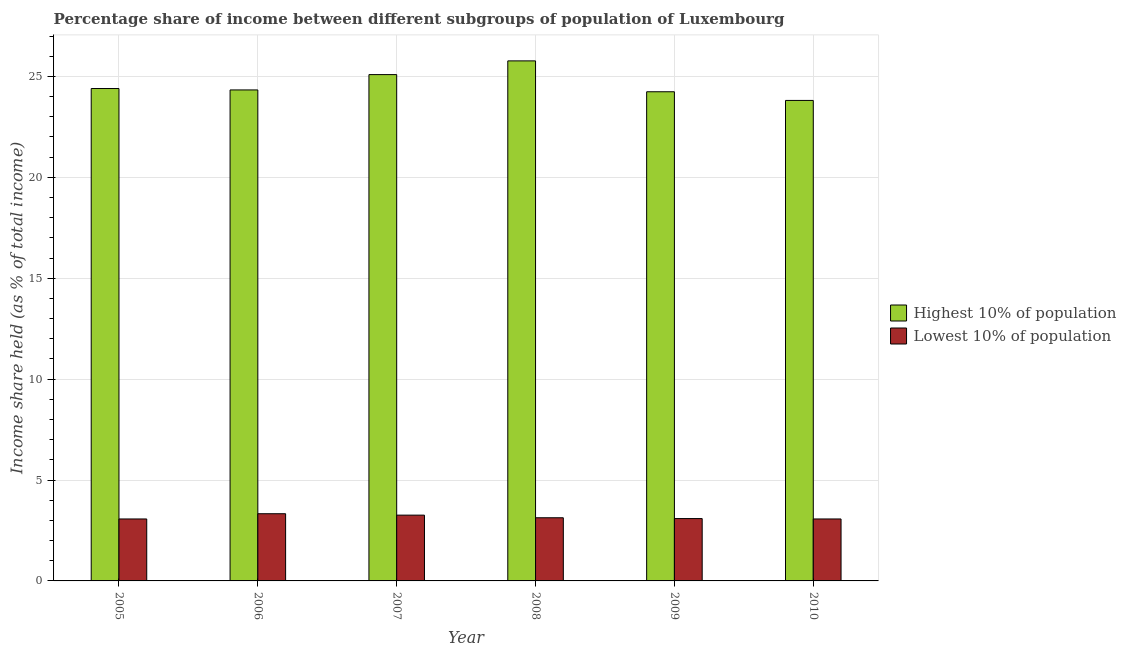How many different coloured bars are there?
Your answer should be very brief. 2. How many groups of bars are there?
Offer a terse response. 6. Are the number of bars on each tick of the X-axis equal?
Your response must be concise. Yes. How many bars are there on the 4th tick from the left?
Give a very brief answer. 2. What is the label of the 4th group of bars from the left?
Offer a terse response. 2008. What is the income share held by highest 10% of the population in 2010?
Your answer should be compact. 23.81. Across all years, what is the maximum income share held by highest 10% of the population?
Your answer should be very brief. 25.77. Across all years, what is the minimum income share held by lowest 10% of the population?
Your response must be concise. 3.07. In which year was the income share held by highest 10% of the population minimum?
Make the answer very short. 2010. What is the total income share held by highest 10% of the population in the graph?
Make the answer very short. 147.64. What is the difference between the income share held by highest 10% of the population in 2005 and that in 2007?
Offer a very short reply. -0.69. What is the difference between the income share held by highest 10% of the population in 2005 and the income share held by lowest 10% of the population in 2008?
Your response must be concise. -1.37. What is the average income share held by lowest 10% of the population per year?
Offer a terse response. 3.16. In how many years, is the income share held by highest 10% of the population greater than 8 %?
Keep it short and to the point. 6. What is the ratio of the income share held by highest 10% of the population in 2006 to that in 2010?
Your answer should be very brief. 1.02. What is the difference between the highest and the second highest income share held by highest 10% of the population?
Provide a short and direct response. 0.68. What is the difference between the highest and the lowest income share held by highest 10% of the population?
Make the answer very short. 1.96. In how many years, is the income share held by highest 10% of the population greater than the average income share held by highest 10% of the population taken over all years?
Your answer should be very brief. 2. Is the sum of the income share held by highest 10% of the population in 2006 and 2010 greater than the maximum income share held by lowest 10% of the population across all years?
Make the answer very short. Yes. What does the 2nd bar from the left in 2009 represents?
Your answer should be very brief. Lowest 10% of population. What does the 2nd bar from the right in 2007 represents?
Offer a very short reply. Highest 10% of population. How many bars are there?
Your answer should be compact. 12. Are all the bars in the graph horizontal?
Offer a terse response. No. How many years are there in the graph?
Provide a succinct answer. 6. Are the values on the major ticks of Y-axis written in scientific E-notation?
Provide a succinct answer. No. Does the graph contain grids?
Provide a succinct answer. Yes. How many legend labels are there?
Your answer should be very brief. 2. How are the legend labels stacked?
Keep it short and to the point. Vertical. What is the title of the graph?
Your response must be concise. Percentage share of income between different subgroups of population of Luxembourg. Does "By country of asylum" appear as one of the legend labels in the graph?
Your answer should be compact. No. What is the label or title of the X-axis?
Provide a succinct answer. Year. What is the label or title of the Y-axis?
Offer a very short reply. Income share held (as % of total income). What is the Income share held (as % of total income) in Highest 10% of population in 2005?
Your answer should be compact. 24.4. What is the Income share held (as % of total income) in Lowest 10% of population in 2005?
Make the answer very short. 3.07. What is the Income share held (as % of total income) in Highest 10% of population in 2006?
Keep it short and to the point. 24.33. What is the Income share held (as % of total income) in Lowest 10% of population in 2006?
Provide a succinct answer. 3.33. What is the Income share held (as % of total income) in Highest 10% of population in 2007?
Offer a very short reply. 25.09. What is the Income share held (as % of total income) in Lowest 10% of population in 2007?
Ensure brevity in your answer.  3.26. What is the Income share held (as % of total income) in Highest 10% of population in 2008?
Your response must be concise. 25.77. What is the Income share held (as % of total income) of Lowest 10% of population in 2008?
Offer a very short reply. 3.13. What is the Income share held (as % of total income) in Highest 10% of population in 2009?
Provide a succinct answer. 24.24. What is the Income share held (as % of total income) of Lowest 10% of population in 2009?
Make the answer very short. 3.09. What is the Income share held (as % of total income) in Highest 10% of population in 2010?
Your answer should be very brief. 23.81. What is the Income share held (as % of total income) of Lowest 10% of population in 2010?
Offer a terse response. 3.07. Across all years, what is the maximum Income share held (as % of total income) of Highest 10% of population?
Keep it short and to the point. 25.77. Across all years, what is the maximum Income share held (as % of total income) in Lowest 10% of population?
Your answer should be very brief. 3.33. Across all years, what is the minimum Income share held (as % of total income) of Highest 10% of population?
Keep it short and to the point. 23.81. Across all years, what is the minimum Income share held (as % of total income) in Lowest 10% of population?
Your answer should be very brief. 3.07. What is the total Income share held (as % of total income) in Highest 10% of population in the graph?
Give a very brief answer. 147.64. What is the total Income share held (as % of total income) of Lowest 10% of population in the graph?
Your response must be concise. 18.95. What is the difference between the Income share held (as % of total income) in Highest 10% of population in 2005 and that in 2006?
Your response must be concise. 0.07. What is the difference between the Income share held (as % of total income) of Lowest 10% of population in 2005 and that in 2006?
Provide a succinct answer. -0.26. What is the difference between the Income share held (as % of total income) of Highest 10% of population in 2005 and that in 2007?
Give a very brief answer. -0.69. What is the difference between the Income share held (as % of total income) in Lowest 10% of population in 2005 and that in 2007?
Keep it short and to the point. -0.19. What is the difference between the Income share held (as % of total income) in Highest 10% of population in 2005 and that in 2008?
Offer a terse response. -1.37. What is the difference between the Income share held (as % of total income) in Lowest 10% of population in 2005 and that in 2008?
Offer a terse response. -0.06. What is the difference between the Income share held (as % of total income) in Highest 10% of population in 2005 and that in 2009?
Offer a very short reply. 0.16. What is the difference between the Income share held (as % of total income) in Lowest 10% of population in 2005 and that in 2009?
Give a very brief answer. -0.02. What is the difference between the Income share held (as % of total income) of Highest 10% of population in 2005 and that in 2010?
Your response must be concise. 0.59. What is the difference between the Income share held (as % of total income) in Highest 10% of population in 2006 and that in 2007?
Offer a very short reply. -0.76. What is the difference between the Income share held (as % of total income) in Lowest 10% of population in 2006 and that in 2007?
Your response must be concise. 0.07. What is the difference between the Income share held (as % of total income) of Highest 10% of population in 2006 and that in 2008?
Your answer should be compact. -1.44. What is the difference between the Income share held (as % of total income) of Lowest 10% of population in 2006 and that in 2008?
Provide a short and direct response. 0.2. What is the difference between the Income share held (as % of total income) of Highest 10% of population in 2006 and that in 2009?
Keep it short and to the point. 0.09. What is the difference between the Income share held (as % of total income) in Lowest 10% of population in 2006 and that in 2009?
Make the answer very short. 0.24. What is the difference between the Income share held (as % of total income) of Highest 10% of population in 2006 and that in 2010?
Offer a terse response. 0.52. What is the difference between the Income share held (as % of total income) of Lowest 10% of population in 2006 and that in 2010?
Your answer should be compact. 0.26. What is the difference between the Income share held (as % of total income) in Highest 10% of population in 2007 and that in 2008?
Keep it short and to the point. -0.68. What is the difference between the Income share held (as % of total income) of Lowest 10% of population in 2007 and that in 2008?
Your answer should be very brief. 0.13. What is the difference between the Income share held (as % of total income) in Highest 10% of population in 2007 and that in 2009?
Your answer should be compact. 0.85. What is the difference between the Income share held (as % of total income) of Lowest 10% of population in 2007 and that in 2009?
Offer a terse response. 0.17. What is the difference between the Income share held (as % of total income) in Highest 10% of population in 2007 and that in 2010?
Your answer should be compact. 1.28. What is the difference between the Income share held (as % of total income) of Lowest 10% of population in 2007 and that in 2010?
Keep it short and to the point. 0.19. What is the difference between the Income share held (as % of total income) of Highest 10% of population in 2008 and that in 2009?
Your response must be concise. 1.53. What is the difference between the Income share held (as % of total income) of Highest 10% of population in 2008 and that in 2010?
Your response must be concise. 1.96. What is the difference between the Income share held (as % of total income) of Highest 10% of population in 2009 and that in 2010?
Offer a very short reply. 0.43. What is the difference between the Income share held (as % of total income) in Lowest 10% of population in 2009 and that in 2010?
Provide a succinct answer. 0.02. What is the difference between the Income share held (as % of total income) of Highest 10% of population in 2005 and the Income share held (as % of total income) of Lowest 10% of population in 2006?
Give a very brief answer. 21.07. What is the difference between the Income share held (as % of total income) of Highest 10% of population in 2005 and the Income share held (as % of total income) of Lowest 10% of population in 2007?
Offer a very short reply. 21.14. What is the difference between the Income share held (as % of total income) of Highest 10% of population in 2005 and the Income share held (as % of total income) of Lowest 10% of population in 2008?
Your answer should be very brief. 21.27. What is the difference between the Income share held (as % of total income) of Highest 10% of population in 2005 and the Income share held (as % of total income) of Lowest 10% of population in 2009?
Your answer should be very brief. 21.31. What is the difference between the Income share held (as % of total income) in Highest 10% of population in 2005 and the Income share held (as % of total income) in Lowest 10% of population in 2010?
Offer a terse response. 21.33. What is the difference between the Income share held (as % of total income) of Highest 10% of population in 2006 and the Income share held (as % of total income) of Lowest 10% of population in 2007?
Provide a short and direct response. 21.07. What is the difference between the Income share held (as % of total income) of Highest 10% of population in 2006 and the Income share held (as % of total income) of Lowest 10% of population in 2008?
Make the answer very short. 21.2. What is the difference between the Income share held (as % of total income) in Highest 10% of population in 2006 and the Income share held (as % of total income) in Lowest 10% of population in 2009?
Your answer should be very brief. 21.24. What is the difference between the Income share held (as % of total income) of Highest 10% of population in 2006 and the Income share held (as % of total income) of Lowest 10% of population in 2010?
Provide a short and direct response. 21.26. What is the difference between the Income share held (as % of total income) in Highest 10% of population in 2007 and the Income share held (as % of total income) in Lowest 10% of population in 2008?
Keep it short and to the point. 21.96. What is the difference between the Income share held (as % of total income) in Highest 10% of population in 2007 and the Income share held (as % of total income) in Lowest 10% of population in 2009?
Your answer should be compact. 22. What is the difference between the Income share held (as % of total income) in Highest 10% of population in 2007 and the Income share held (as % of total income) in Lowest 10% of population in 2010?
Offer a terse response. 22.02. What is the difference between the Income share held (as % of total income) in Highest 10% of population in 2008 and the Income share held (as % of total income) in Lowest 10% of population in 2009?
Give a very brief answer. 22.68. What is the difference between the Income share held (as % of total income) of Highest 10% of population in 2008 and the Income share held (as % of total income) of Lowest 10% of population in 2010?
Make the answer very short. 22.7. What is the difference between the Income share held (as % of total income) in Highest 10% of population in 2009 and the Income share held (as % of total income) in Lowest 10% of population in 2010?
Provide a short and direct response. 21.17. What is the average Income share held (as % of total income) of Highest 10% of population per year?
Ensure brevity in your answer.  24.61. What is the average Income share held (as % of total income) in Lowest 10% of population per year?
Make the answer very short. 3.16. In the year 2005, what is the difference between the Income share held (as % of total income) of Highest 10% of population and Income share held (as % of total income) of Lowest 10% of population?
Your response must be concise. 21.33. In the year 2006, what is the difference between the Income share held (as % of total income) of Highest 10% of population and Income share held (as % of total income) of Lowest 10% of population?
Your answer should be very brief. 21. In the year 2007, what is the difference between the Income share held (as % of total income) in Highest 10% of population and Income share held (as % of total income) in Lowest 10% of population?
Your answer should be compact. 21.83. In the year 2008, what is the difference between the Income share held (as % of total income) of Highest 10% of population and Income share held (as % of total income) of Lowest 10% of population?
Provide a succinct answer. 22.64. In the year 2009, what is the difference between the Income share held (as % of total income) in Highest 10% of population and Income share held (as % of total income) in Lowest 10% of population?
Provide a short and direct response. 21.15. In the year 2010, what is the difference between the Income share held (as % of total income) in Highest 10% of population and Income share held (as % of total income) in Lowest 10% of population?
Ensure brevity in your answer.  20.74. What is the ratio of the Income share held (as % of total income) in Lowest 10% of population in 2005 to that in 2006?
Keep it short and to the point. 0.92. What is the ratio of the Income share held (as % of total income) of Highest 10% of population in 2005 to that in 2007?
Ensure brevity in your answer.  0.97. What is the ratio of the Income share held (as % of total income) in Lowest 10% of population in 2005 to that in 2007?
Offer a very short reply. 0.94. What is the ratio of the Income share held (as % of total income) in Highest 10% of population in 2005 to that in 2008?
Your answer should be very brief. 0.95. What is the ratio of the Income share held (as % of total income) of Lowest 10% of population in 2005 to that in 2008?
Ensure brevity in your answer.  0.98. What is the ratio of the Income share held (as % of total income) of Highest 10% of population in 2005 to that in 2009?
Your answer should be very brief. 1.01. What is the ratio of the Income share held (as % of total income) of Lowest 10% of population in 2005 to that in 2009?
Your answer should be very brief. 0.99. What is the ratio of the Income share held (as % of total income) in Highest 10% of population in 2005 to that in 2010?
Offer a very short reply. 1.02. What is the ratio of the Income share held (as % of total income) in Highest 10% of population in 2006 to that in 2007?
Keep it short and to the point. 0.97. What is the ratio of the Income share held (as % of total income) of Lowest 10% of population in 2006 to that in 2007?
Give a very brief answer. 1.02. What is the ratio of the Income share held (as % of total income) in Highest 10% of population in 2006 to that in 2008?
Your answer should be very brief. 0.94. What is the ratio of the Income share held (as % of total income) in Lowest 10% of population in 2006 to that in 2008?
Offer a terse response. 1.06. What is the ratio of the Income share held (as % of total income) of Highest 10% of population in 2006 to that in 2009?
Provide a succinct answer. 1. What is the ratio of the Income share held (as % of total income) in Lowest 10% of population in 2006 to that in 2009?
Ensure brevity in your answer.  1.08. What is the ratio of the Income share held (as % of total income) of Highest 10% of population in 2006 to that in 2010?
Provide a short and direct response. 1.02. What is the ratio of the Income share held (as % of total income) in Lowest 10% of population in 2006 to that in 2010?
Keep it short and to the point. 1.08. What is the ratio of the Income share held (as % of total income) of Highest 10% of population in 2007 to that in 2008?
Offer a terse response. 0.97. What is the ratio of the Income share held (as % of total income) of Lowest 10% of population in 2007 to that in 2008?
Your answer should be compact. 1.04. What is the ratio of the Income share held (as % of total income) of Highest 10% of population in 2007 to that in 2009?
Offer a terse response. 1.04. What is the ratio of the Income share held (as % of total income) in Lowest 10% of population in 2007 to that in 2009?
Your response must be concise. 1.05. What is the ratio of the Income share held (as % of total income) in Highest 10% of population in 2007 to that in 2010?
Offer a terse response. 1.05. What is the ratio of the Income share held (as % of total income) in Lowest 10% of population in 2007 to that in 2010?
Give a very brief answer. 1.06. What is the ratio of the Income share held (as % of total income) in Highest 10% of population in 2008 to that in 2009?
Offer a terse response. 1.06. What is the ratio of the Income share held (as % of total income) of Lowest 10% of population in 2008 to that in 2009?
Provide a short and direct response. 1.01. What is the ratio of the Income share held (as % of total income) in Highest 10% of population in 2008 to that in 2010?
Provide a short and direct response. 1.08. What is the ratio of the Income share held (as % of total income) of Lowest 10% of population in 2008 to that in 2010?
Give a very brief answer. 1.02. What is the ratio of the Income share held (as % of total income) in Highest 10% of population in 2009 to that in 2010?
Your answer should be very brief. 1.02. What is the ratio of the Income share held (as % of total income) of Lowest 10% of population in 2009 to that in 2010?
Ensure brevity in your answer.  1.01. What is the difference between the highest and the second highest Income share held (as % of total income) of Highest 10% of population?
Give a very brief answer. 0.68. What is the difference between the highest and the second highest Income share held (as % of total income) of Lowest 10% of population?
Offer a terse response. 0.07. What is the difference between the highest and the lowest Income share held (as % of total income) of Highest 10% of population?
Provide a succinct answer. 1.96. What is the difference between the highest and the lowest Income share held (as % of total income) of Lowest 10% of population?
Your answer should be compact. 0.26. 